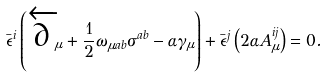<formula> <loc_0><loc_0><loc_500><loc_500>\bar { \epsilon } ^ { i } \left ( \overleftarrow { \partial } _ { \mu } + \frac { 1 } { 2 } \omega _ { \mu a b } \sigma ^ { a b } - \alpha \gamma _ { \mu } \right ) + \bar { \epsilon } ^ { j } \left ( 2 \alpha A _ { \mu } ^ { i j } \right ) = 0 .</formula> 